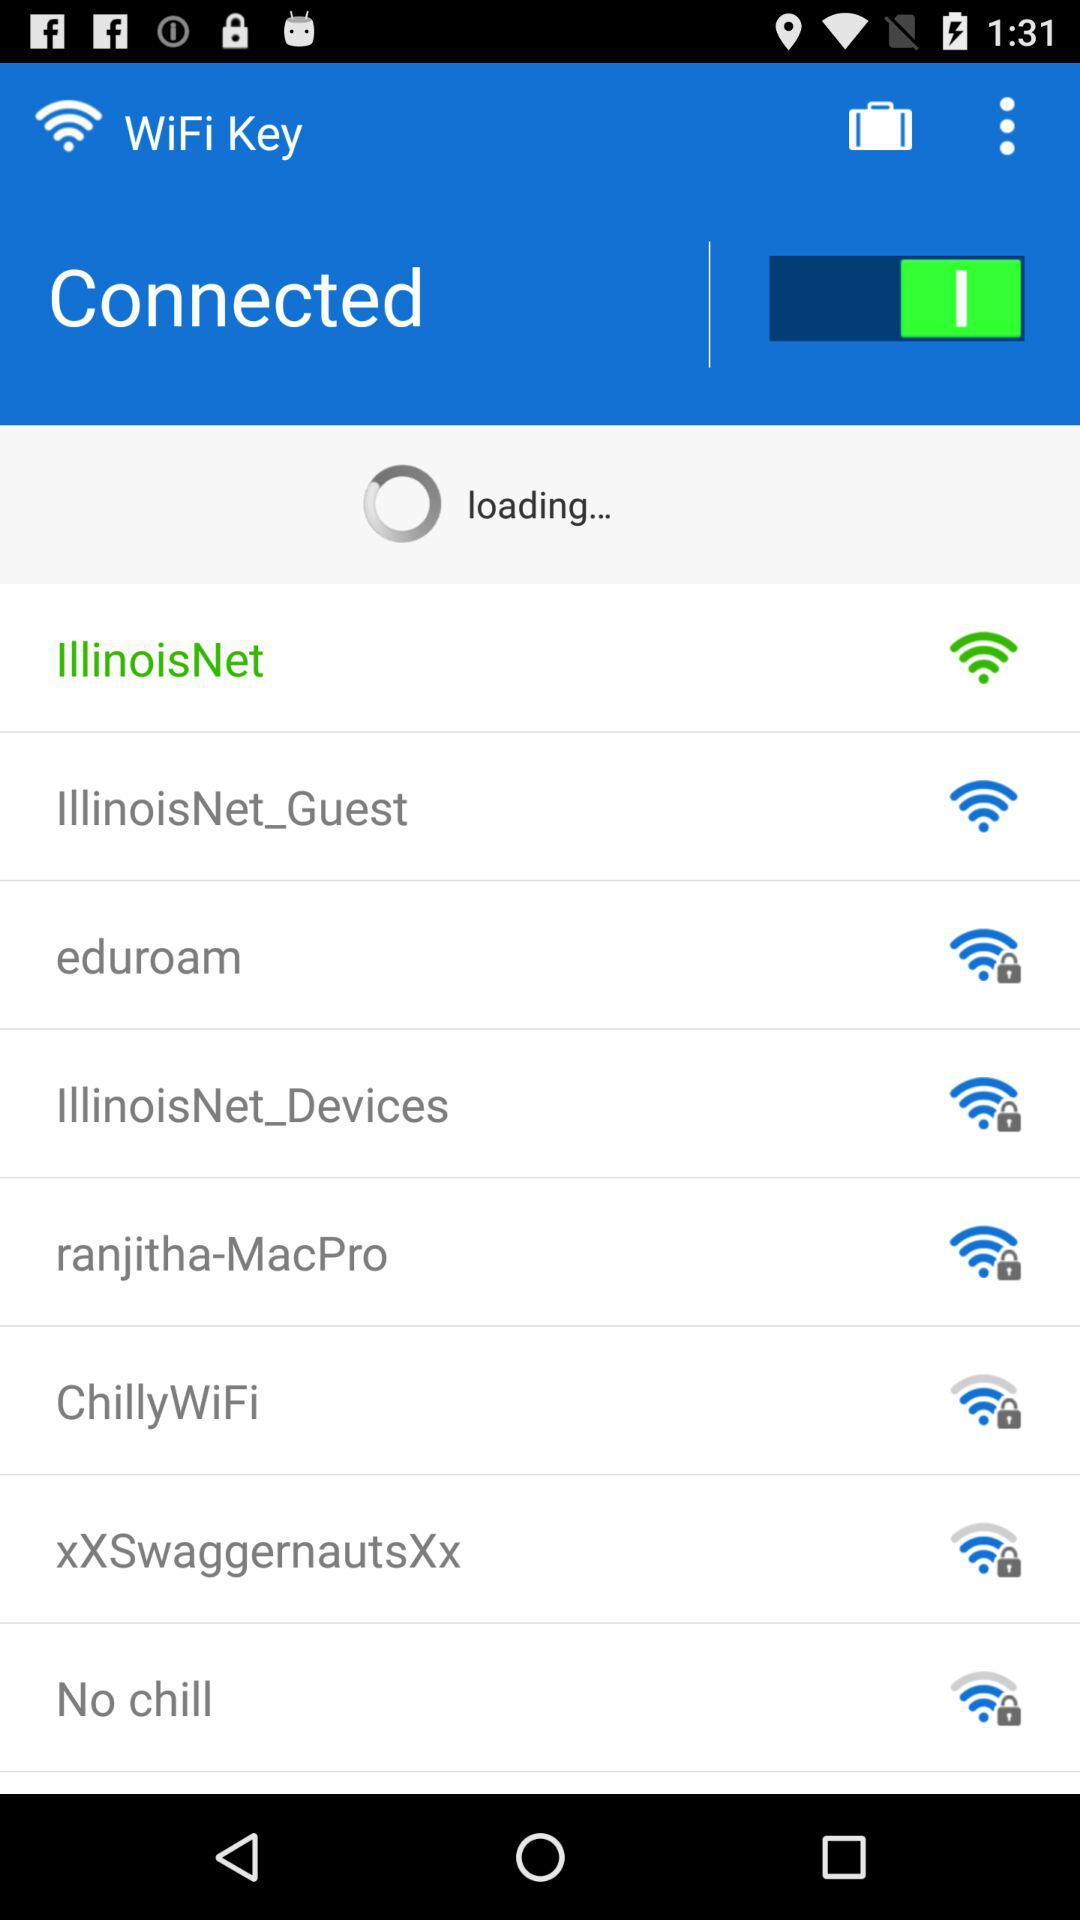What is the application name? The application name is "WiFi Key". 